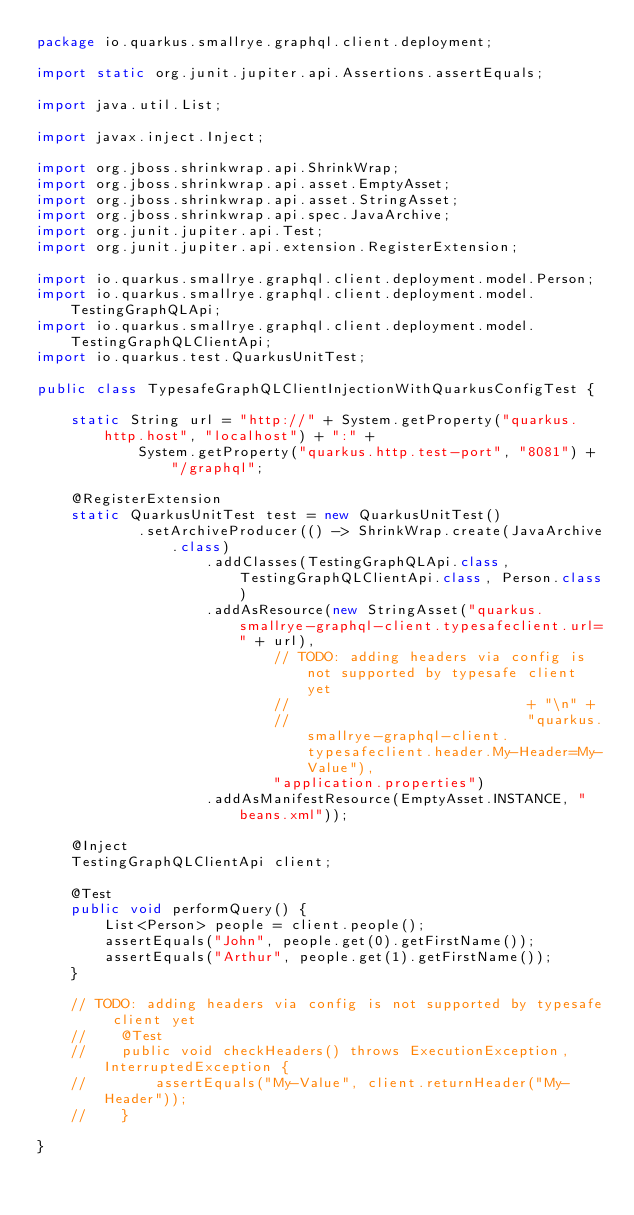<code> <loc_0><loc_0><loc_500><loc_500><_Java_>package io.quarkus.smallrye.graphql.client.deployment;

import static org.junit.jupiter.api.Assertions.assertEquals;

import java.util.List;

import javax.inject.Inject;

import org.jboss.shrinkwrap.api.ShrinkWrap;
import org.jboss.shrinkwrap.api.asset.EmptyAsset;
import org.jboss.shrinkwrap.api.asset.StringAsset;
import org.jboss.shrinkwrap.api.spec.JavaArchive;
import org.junit.jupiter.api.Test;
import org.junit.jupiter.api.extension.RegisterExtension;

import io.quarkus.smallrye.graphql.client.deployment.model.Person;
import io.quarkus.smallrye.graphql.client.deployment.model.TestingGraphQLApi;
import io.quarkus.smallrye.graphql.client.deployment.model.TestingGraphQLClientApi;
import io.quarkus.test.QuarkusUnitTest;

public class TypesafeGraphQLClientInjectionWithQuarkusConfigTest {

    static String url = "http://" + System.getProperty("quarkus.http.host", "localhost") + ":" +
            System.getProperty("quarkus.http.test-port", "8081") + "/graphql";

    @RegisterExtension
    static QuarkusUnitTest test = new QuarkusUnitTest()
            .setArchiveProducer(() -> ShrinkWrap.create(JavaArchive.class)
                    .addClasses(TestingGraphQLApi.class, TestingGraphQLClientApi.class, Person.class)
                    .addAsResource(new StringAsset("quarkus.smallrye-graphql-client.typesafeclient.url=" + url),
                            // TODO: adding headers via config is not supported by typesafe client yet
                            //                            + "\n" +
                            //                            "quarkus.smallrye-graphql-client.typesafeclient.header.My-Header=My-Value"),
                            "application.properties")
                    .addAsManifestResource(EmptyAsset.INSTANCE, "beans.xml"));

    @Inject
    TestingGraphQLClientApi client;

    @Test
    public void performQuery() {
        List<Person> people = client.people();
        assertEquals("John", people.get(0).getFirstName());
        assertEquals("Arthur", people.get(1).getFirstName());
    }

    // TODO: adding headers via config is not supported by typesafe client yet
    //    @Test
    //    public void checkHeaders() throws ExecutionException, InterruptedException {
    //        assertEquals("My-Value", client.returnHeader("My-Header"));
    //    }

}
</code> 